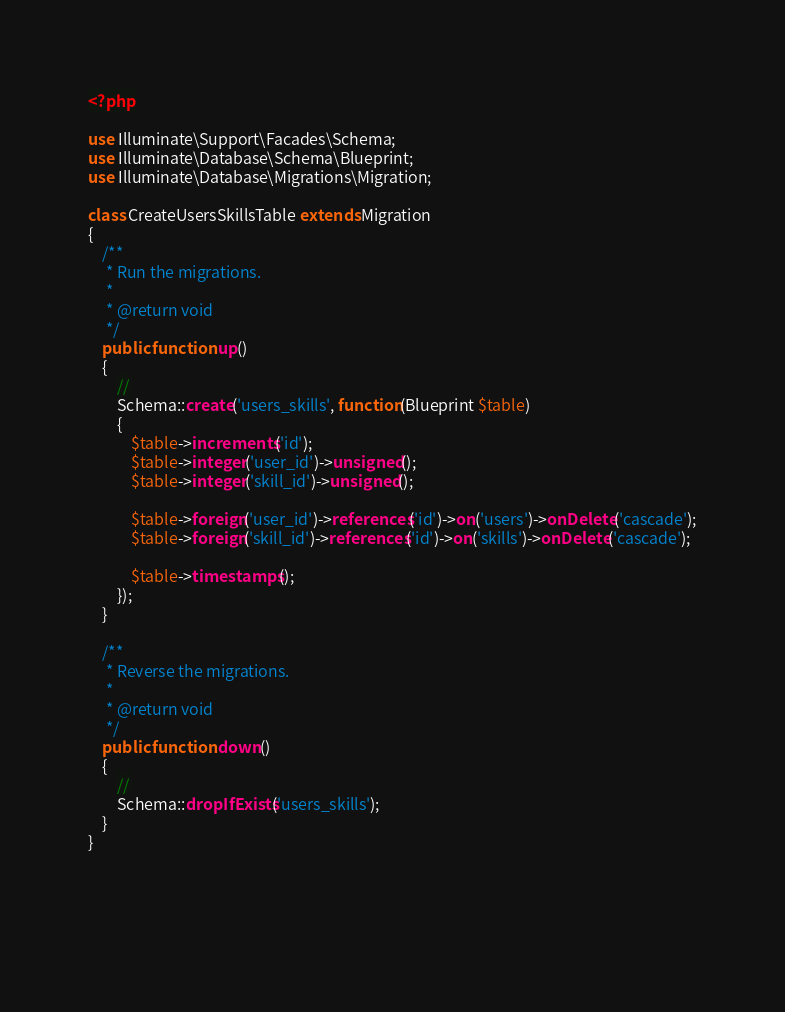Convert code to text. <code><loc_0><loc_0><loc_500><loc_500><_PHP_><?php

use Illuminate\Support\Facades\Schema;
use Illuminate\Database\Schema\Blueprint;
use Illuminate\Database\Migrations\Migration;

class CreateUsersSkillsTable extends Migration
{
    /**
     * Run the migrations.
     *
     * @return void
     */
    public function up()
    {
        //
        Schema::create('users_skills', function(Blueprint $table)
        {
            $table->increments('id');
            $table->integer('user_id')->unsigned();
            $table->integer('skill_id')->unsigned();

            $table->foreign('user_id')->references('id')->on('users')->onDelete('cascade');
            $table->foreign('skill_id')->references('id')->on('skills')->onDelete('cascade');

            $table->timestamps();
        });
    }

    /**
     * Reverse the migrations.
     *
     * @return void
     */
    public function down()
    {
        //
        Schema::dropIfExists('users_skills');
    }
}



 </code> 